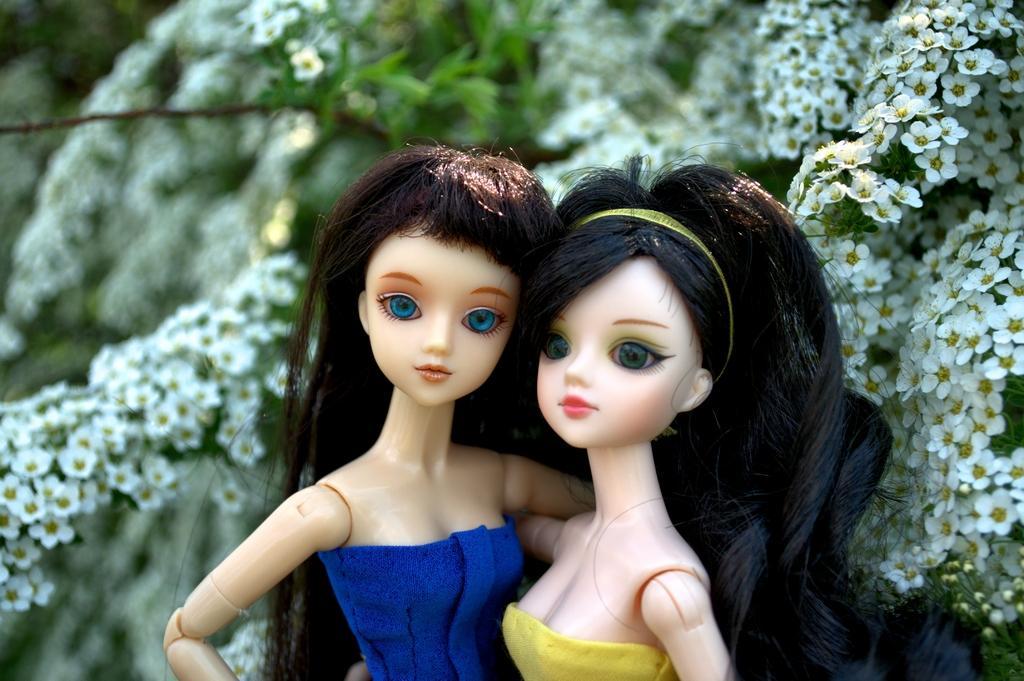In one or two sentences, can you explain what this image depicts? In this image we can see two dolls. One is wearing yellow color dress and the other one is wearing blue color dress. Behind them flowers are present. 